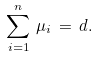<formula> <loc_0><loc_0><loc_500><loc_500>\sum _ { i = 1 } ^ { n } \, \mu _ { i } \, = \, d .</formula> 